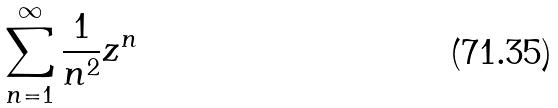<formula> <loc_0><loc_0><loc_500><loc_500>\sum _ { n = 1 } ^ { \infty } \frac { 1 } { n ^ { 2 } } z ^ { n }</formula> 